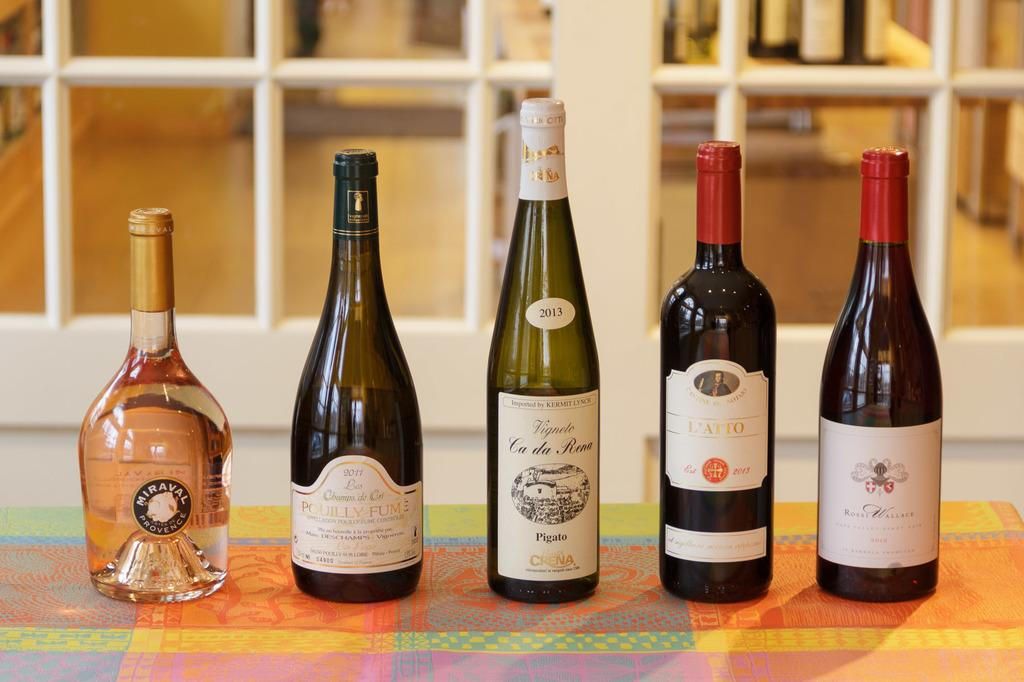Provide a one-sentence caption for the provided image. An assortment of five different liquor bottles, like Miraval and Ca da Rena, are set up side by side. 